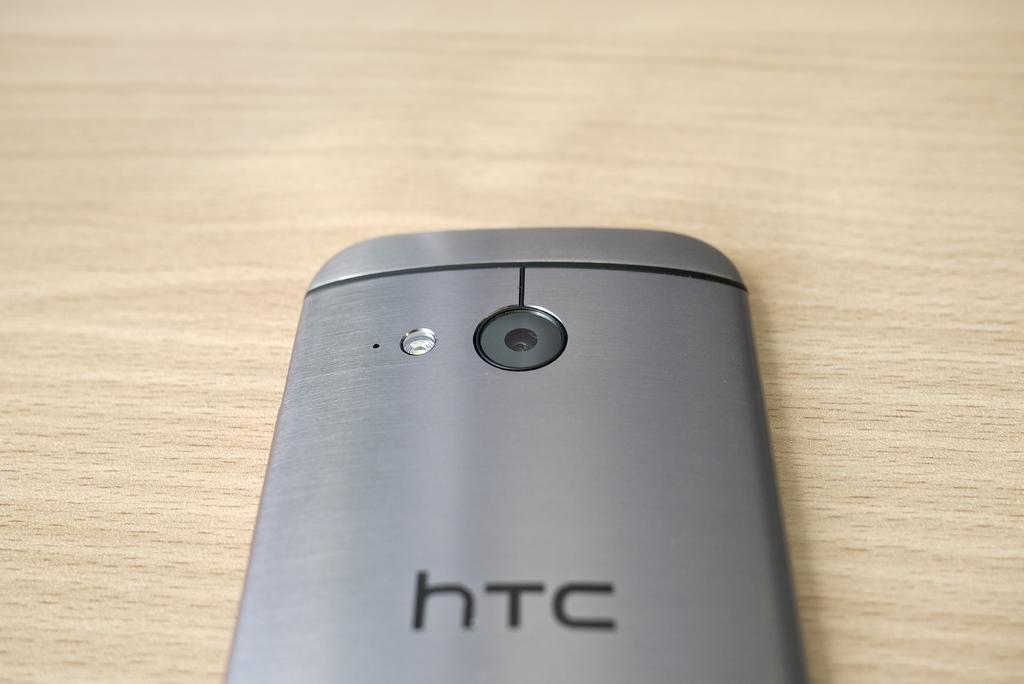<image>
Create a compact narrative representing the image presented. back of brushed metal htc phone on a wooden background 